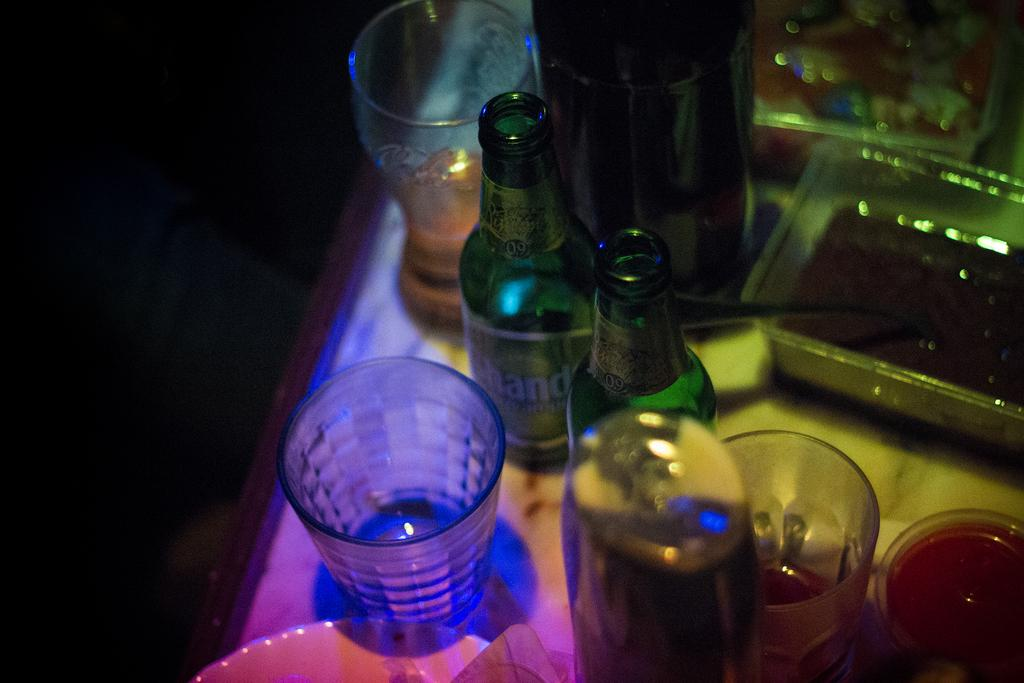<image>
Present a compact description of the photo's key features. a dark bar table shows glasses and bottles with letters HAND on it 